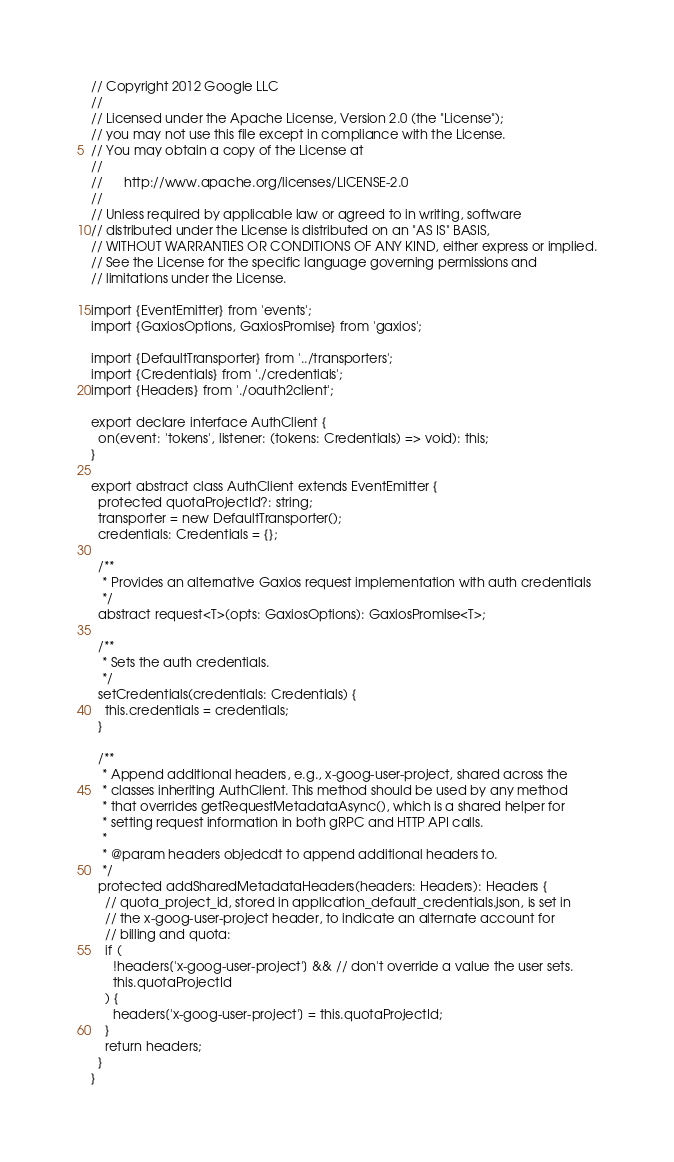Convert code to text. <code><loc_0><loc_0><loc_500><loc_500><_TypeScript_>// Copyright 2012 Google LLC
//
// Licensed under the Apache License, Version 2.0 (the "License");
// you may not use this file except in compliance with the License.
// You may obtain a copy of the License at
//
//      http://www.apache.org/licenses/LICENSE-2.0
//
// Unless required by applicable law or agreed to in writing, software
// distributed under the License is distributed on an "AS IS" BASIS,
// WITHOUT WARRANTIES OR CONDITIONS OF ANY KIND, either express or implied.
// See the License for the specific language governing permissions and
// limitations under the License.

import {EventEmitter} from 'events';
import {GaxiosOptions, GaxiosPromise} from 'gaxios';

import {DefaultTransporter} from '../transporters';
import {Credentials} from './credentials';
import {Headers} from './oauth2client';

export declare interface AuthClient {
  on(event: 'tokens', listener: (tokens: Credentials) => void): this;
}

export abstract class AuthClient extends EventEmitter {
  protected quotaProjectId?: string;
  transporter = new DefaultTransporter();
  credentials: Credentials = {};

  /**
   * Provides an alternative Gaxios request implementation with auth credentials
   */
  abstract request<T>(opts: GaxiosOptions): GaxiosPromise<T>;

  /**
   * Sets the auth credentials.
   */
  setCredentials(credentials: Credentials) {
    this.credentials = credentials;
  }

  /**
   * Append additional headers, e.g., x-goog-user-project, shared across the
   * classes inheriting AuthClient. This method should be used by any method
   * that overrides getRequestMetadataAsync(), which is a shared helper for
   * setting request information in both gRPC and HTTP API calls.
   *
   * @param headers objedcdt to append additional headers to.
   */
  protected addSharedMetadataHeaders(headers: Headers): Headers {
    // quota_project_id, stored in application_default_credentials.json, is set in
    // the x-goog-user-project header, to indicate an alternate account for
    // billing and quota:
    if (
      !headers['x-goog-user-project'] && // don't override a value the user sets.
      this.quotaProjectId
    ) {
      headers['x-goog-user-project'] = this.quotaProjectId;
    }
    return headers;
  }
}
</code> 